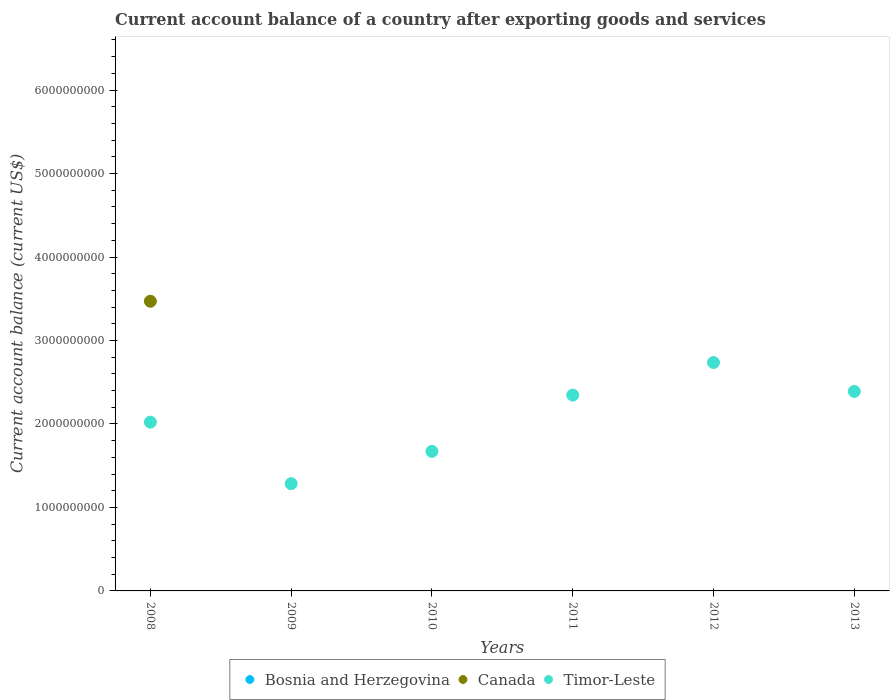How many different coloured dotlines are there?
Provide a succinct answer. 2. Is the number of dotlines equal to the number of legend labels?
Provide a succinct answer. No. What is the account balance in Canada in 2008?
Provide a short and direct response. 3.47e+09. Across all years, what is the maximum account balance in Timor-Leste?
Your answer should be very brief. 2.74e+09. Across all years, what is the minimum account balance in Timor-Leste?
Make the answer very short. 1.28e+09. What is the total account balance in Canada in the graph?
Your response must be concise. 3.47e+09. What is the difference between the account balance in Timor-Leste in 2008 and that in 2012?
Offer a terse response. -7.14e+08. What is the difference between the account balance in Timor-Leste in 2008 and the account balance in Bosnia and Herzegovina in 2009?
Ensure brevity in your answer.  2.02e+09. What is the average account balance in Canada per year?
Your answer should be very brief. 5.78e+08. In how many years, is the account balance in Canada greater than 4400000000 US$?
Give a very brief answer. 0. What is the ratio of the account balance in Timor-Leste in 2010 to that in 2013?
Give a very brief answer. 0.7. What is the difference between the highest and the second highest account balance in Timor-Leste?
Your answer should be very brief. 3.46e+08. What is the difference between the highest and the lowest account balance in Canada?
Make the answer very short. 3.47e+09. Is the sum of the account balance in Timor-Leste in 2009 and 2011 greater than the maximum account balance in Canada across all years?
Ensure brevity in your answer.  Yes. Is the account balance in Timor-Leste strictly greater than the account balance in Canada over the years?
Your response must be concise. No. How many dotlines are there?
Provide a short and direct response. 2. What is the difference between two consecutive major ticks on the Y-axis?
Offer a terse response. 1.00e+09. Does the graph contain grids?
Your response must be concise. No. Where does the legend appear in the graph?
Ensure brevity in your answer.  Bottom center. How are the legend labels stacked?
Provide a short and direct response. Horizontal. What is the title of the graph?
Provide a succinct answer. Current account balance of a country after exporting goods and services. Does "Dominican Republic" appear as one of the legend labels in the graph?
Provide a short and direct response. No. What is the label or title of the X-axis?
Give a very brief answer. Years. What is the label or title of the Y-axis?
Keep it short and to the point. Current account balance (current US$). What is the Current account balance (current US$) of Bosnia and Herzegovina in 2008?
Keep it short and to the point. 0. What is the Current account balance (current US$) of Canada in 2008?
Give a very brief answer. 3.47e+09. What is the Current account balance (current US$) in Timor-Leste in 2008?
Give a very brief answer. 2.02e+09. What is the Current account balance (current US$) in Canada in 2009?
Provide a short and direct response. 0. What is the Current account balance (current US$) of Timor-Leste in 2009?
Provide a short and direct response. 1.28e+09. What is the Current account balance (current US$) of Bosnia and Herzegovina in 2010?
Ensure brevity in your answer.  0. What is the Current account balance (current US$) in Timor-Leste in 2010?
Provide a short and direct response. 1.67e+09. What is the Current account balance (current US$) in Bosnia and Herzegovina in 2011?
Your response must be concise. 0. What is the Current account balance (current US$) of Timor-Leste in 2011?
Give a very brief answer. 2.35e+09. What is the Current account balance (current US$) in Canada in 2012?
Give a very brief answer. 0. What is the Current account balance (current US$) in Timor-Leste in 2012?
Your answer should be compact. 2.74e+09. What is the Current account balance (current US$) of Bosnia and Herzegovina in 2013?
Your response must be concise. 0. What is the Current account balance (current US$) of Canada in 2013?
Provide a succinct answer. 0. What is the Current account balance (current US$) in Timor-Leste in 2013?
Your answer should be very brief. 2.39e+09. Across all years, what is the maximum Current account balance (current US$) in Canada?
Keep it short and to the point. 3.47e+09. Across all years, what is the maximum Current account balance (current US$) of Timor-Leste?
Provide a short and direct response. 2.74e+09. Across all years, what is the minimum Current account balance (current US$) in Canada?
Provide a short and direct response. 0. Across all years, what is the minimum Current account balance (current US$) in Timor-Leste?
Provide a short and direct response. 1.28e+09. What is the total Current account balance (current US$) in Canada in the graph?
Your answer should be compact. 3.47e+09. What is the total Current account balance (current US$) in Timor-Leste in the graph?
Keep it short and to the point. 1.25e+1. What is the difference between the Current account balance (current US$) in Timor-Leste in 2008 and that in 2009?
Provide a short and direct response. 7.37e+08. What is the difference between the Current account balance (current US$) of Timor-Leste in 2008 and that in 2010?
Your answer should be very brief. 3.50e+08. What is the difference between the Current account balance (current US$) of Timor-Leste in 2008 and that in 2011?
Your response must be concise. -3.24e+08. What is the difference between the Current account balance (current US$) of Timor-Leste in 2008 and that in 2012?
Your answer should be very brief. -7.14e+08. What is the difference between the Current account balance (current US$) of Timor-Leste in 2008 and that in 2013?
Your response must be concise. -3.68e+08. What is the difference between the Current account balance (current US$) in Timor-Leste in 2009 and that in 2010?
Provide a succinct answer. -3.86e+08. What is the difference between the Current account balance (current US$) in Timor-Leste in 2009 and that in 2011?
Provide a succinct answer. -1.06e+09. What is the difference between the Current account balance (current US$) in Timor-Leste in 2009 and that in 2012?
Provide a short and direct response. -1.45e+09. What is the difference between the Current account balance (current US$) in Timor-Leste in 2009 and that in 2013?
Offer a very short reply. -1.11e+09. What is the difference between the Current account balance (current US$) in Timor-Leste in 2010 and that in 2011?
Your response must be concise. -6.75e+08. What is the difference between the Current account balance (current US$) of Timor-Leste in 2010 and that in 2012?
Your answer should be compact. -1.06e+09. What is the difference between the Current account balance (current US$) in Timor-Leste in 2010 and that in 2013?
Your response must be concise. -7.19e+08. What is the difference between the Current account balance (current US$) of Timor-Leste in 2011 and that in 2012?
Keep it short and to the point. -3.90e+08. What is the difference between the Current account balance (current US$) of Timor-Leste in 2011 and that in 2013?
Your answer should be very brief. -4.40e+07. What is the difference between the Current account balance (current US$) of Timor-Leste in 2012 and that in 2013?
Make the answer very short. 3.46e+08. What is the difference between the Current account balance (current US$) of Canada in 2008 and the Current account balance (current US$) of Timor-Leste in 2009?
Your response must be concise. 2.19e+09. What is the difference between the Current account balance (current US$) in Canada in 2008 and the Current account balance (current US$) in Timor-Leste in 2010?
Make the answer very short. 1.80e+09. What is the difference between the Current account balance (current US$) in Canada in 2008 and the Current account balance (current US$) in Timor-Leste in 2011?
Offer a terse response. 1.12e+09. What is the difference between the Current account balance (current US$) in Canada in 2008 and the Current account balance (current US$) in Timor-Leste in 2012?
Make the answer very short. 7.34e+08. What is the difference between the Current account balance (current US$) of Canada in 2008 and the Current account balance (current US$) of Timor-Leste in 2013?
Keep it short and to the point. 1.08e+09. What is the average Current account balance (current US$) of Canada per year?
Ensure brevity in your answer.  5.78e+08. What is the average Current account balance (current US$) in Timor-Leste per year?
Provide a succinct answer. 2.08e+09. In the year 2008, what is the difference between the Current account balance (current US$) in Canada and Current account balance (current US$) in Timor-Leste?
Your response must be concise. 1.45e+09. What is the ratio of the Current account balance (current US$) in Timor-Leste in 2008 to that in 2009?
Ensure brevity in your answer.  1.57. What is the ratio of the Current account balance (current US$) in Timor-Leste in 2008 to that in 2010?
Offer a very short reply. 1.21. What is the ratio of the Current account balance (current US$) in Timor-Leste in 2008 to that in 2011?
Give a very brief answer. 0.86. What is the ratio of the Current account balance (current US$) in Timor-Leste in 2008 to that in 2012?
Provide a short and direct response. 0.74. What is the ratio of the Current account balance (current US$) in Timor-Leste in 2008 to that in 2013?
Your answer should be very brief. 0.85. What is the ratio of the Current account balance (current US$) of Timor-Leste in 2009 to that in 2010?
Keep it short and to the point. 0.77. What is the ratio of the Current account balance (current US$) of Timor-Leste in 2009 to that in 2011?
Provide a succinct answer. 0.55. What is the ratio of the Current account balance (current US$) of Timor-Leste in 2009 to that in 2012?
Keep it short and to the point. 0.47. What is the ratio of the Current account balance (current US$) in Timor-Leste in 2009 to that in 2013?
Provide a succinct answer. 0.54. What is the ratio of the Current account balance (current US$) in Timor-Leste in 2010 to that in 2011?
Your answer should be compact. 0.71. What is the ratio of the Current account balance (current US$) of Timor-Leste in 2010 to that in 2012?
Your answer should be very brief. 0.61. What is the ratio of the Current account balance (current US$) in Timor-Leste in 2010 to that in 2013?
Give a very brief answer. 0.7. What is the ratio of the Current account balance (current US$) of Timor-Leste in 2011 to that in 2012?
Offer a very short reply. 0.86. What is the ratio of the Current account balance (current US$) in Timor-Leste in 2011 to that in 2013?
Offer a terse response. 0.98. What is the ratio of the Current account balance (current US$) of Timor-Leste in 2012 to that in 2013?
Offer a very short reply. 1.14. What is the difference between the highest and the second highest Current account balance (current US$) of Timor-Leste?
Offer a very short reply. 3.46e+08. What is the difference between the highest and the lowest Current account balance (current US$) in Canada?
Provide a succinct answer. 3.47e+09. What is the difference between the highest and the lowest Current account balance (current US$) of Timor-Leste?
Offer a terse response. 1.45e+09. 